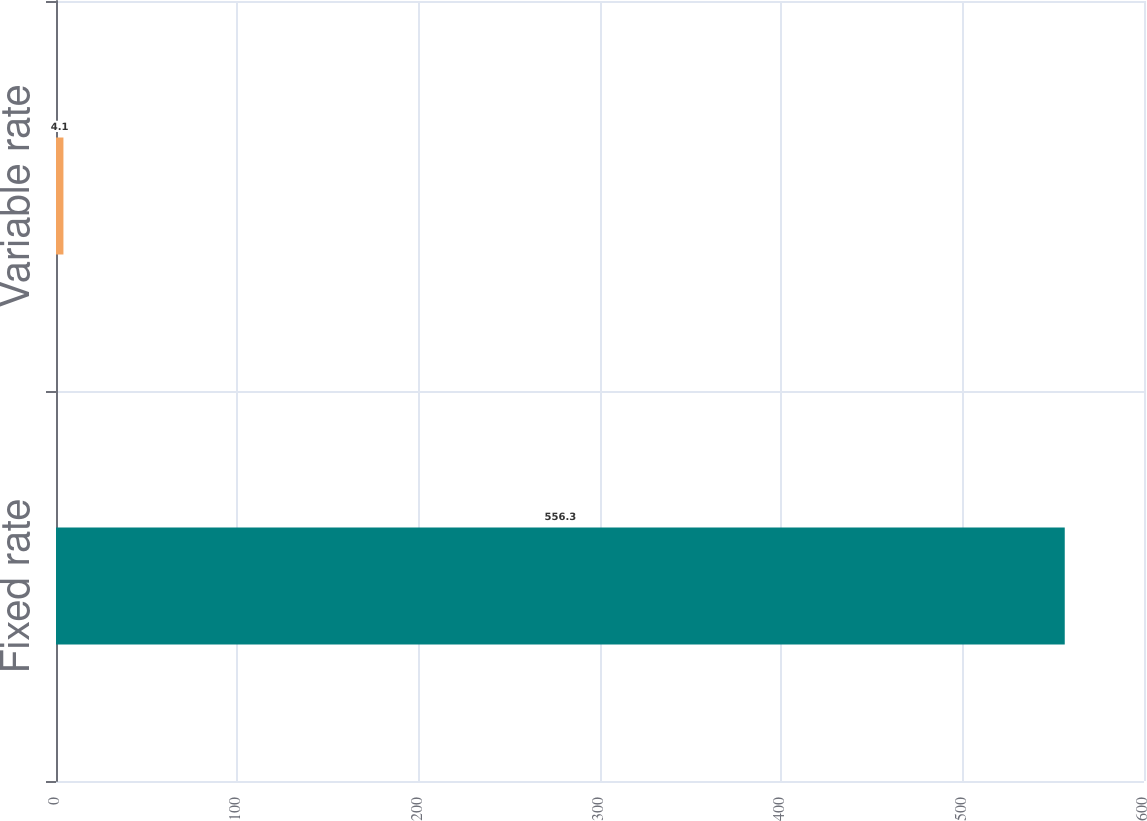Convert chart. <chart><loc_0><loc_0><loc_500><loc_500><bar_chart><fcel>Fixed rate<fcel>Variable rate<nl><fcel>556.3<fcel>4.1<nl></chart> 